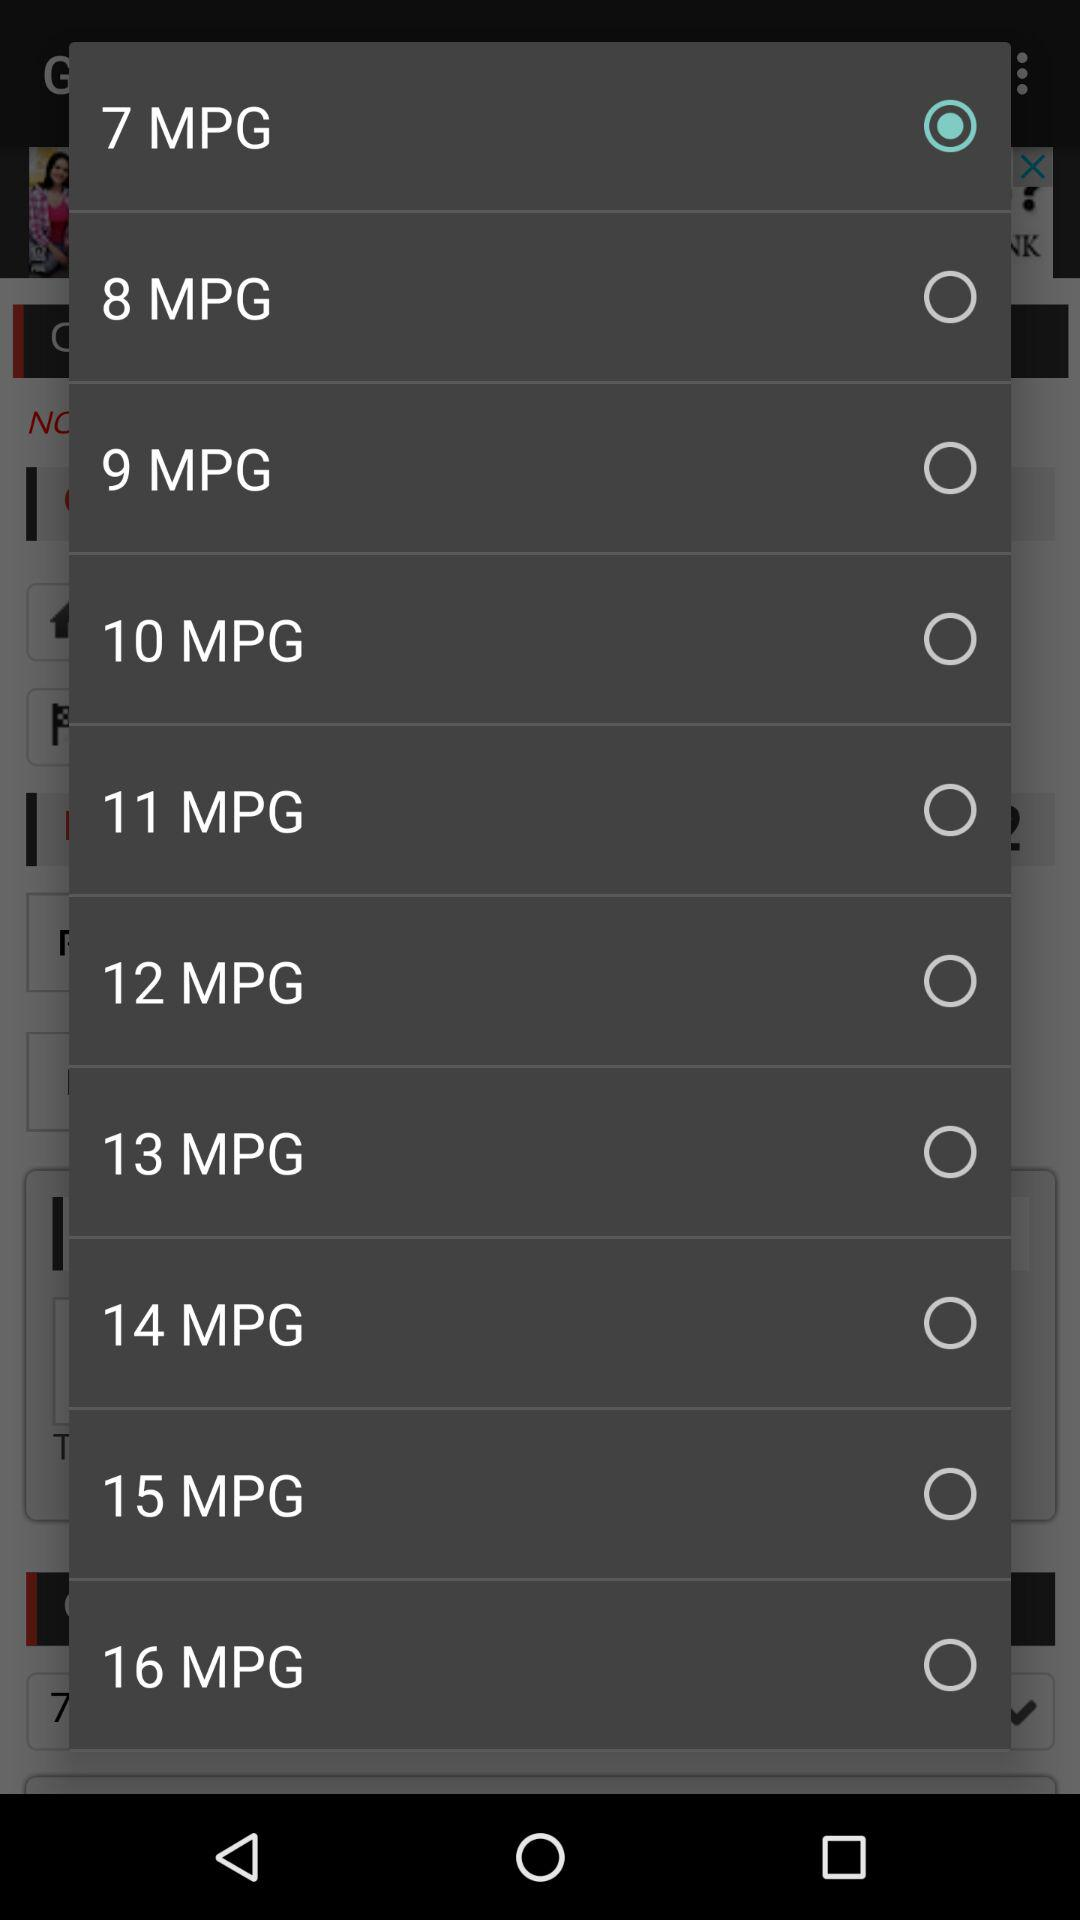What is the selected option? The selected option is "7 MPG". 